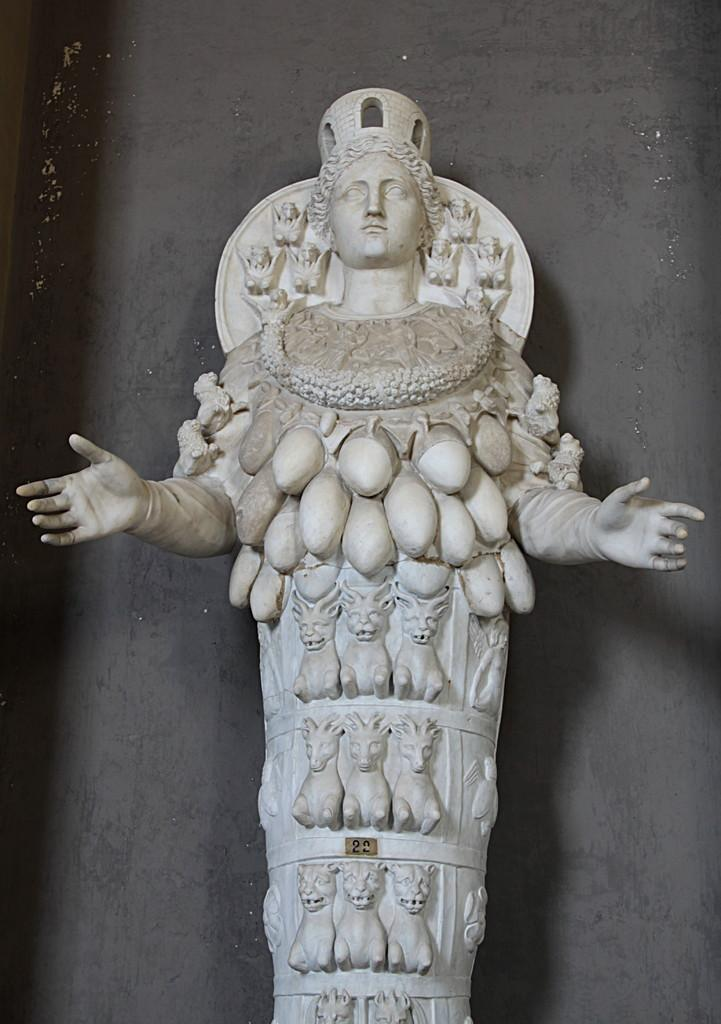What is the main subject of the image? There is a white-colored statue in the image. Can you describe the statue? The statue is of a girl. Are there any additional details on the statue? Yes, there are engravings on the statue. What can be seen in the background of the image? There is a wall in the background of the image. How many flags can be seen on the statue in the image? There are no flags present on the statue in the image. Can you describe the girl statue jumping in the image? The girl statue is not depicted as jumping in the image; it is stationary. 